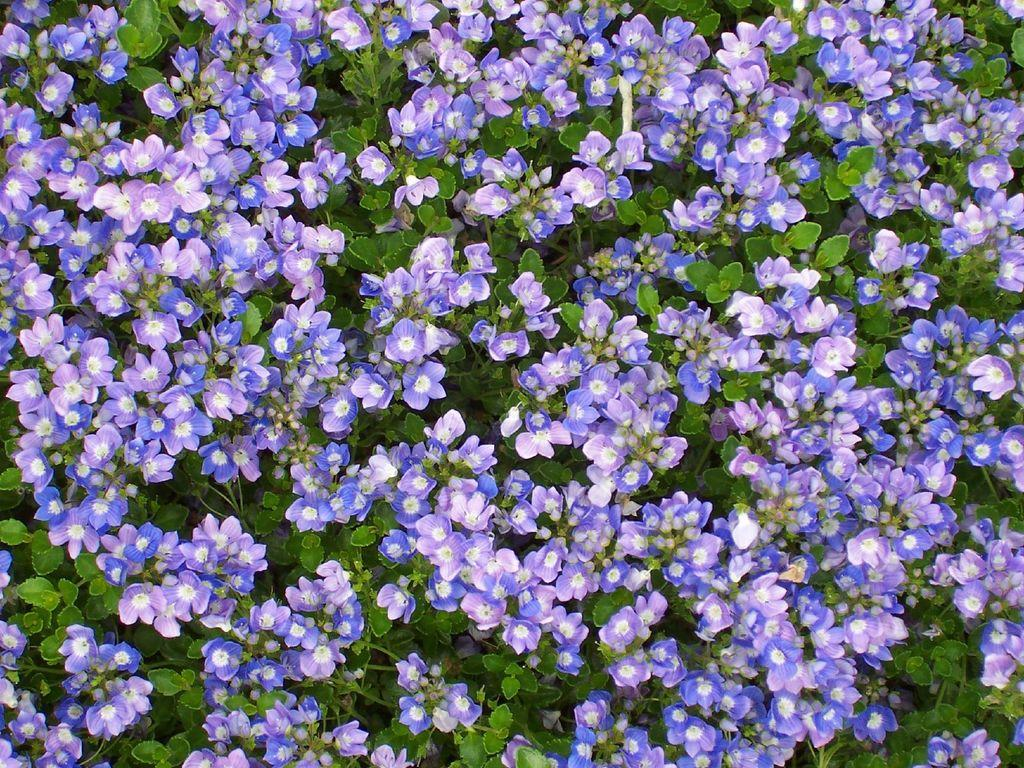What type of living organisms can be seen in the image? Flowers and plants can be seen in the image. Can you describe the specific types of plants or flowers visible in the image? Unfortunately, the provided facts do not specify the types of flowers or plants in the image. What type of calendar is displayed on the wall in the image? There is no mention of a calendar in the provided facts, so it cannot be determined if there is one present in the image. How does the toothpaste help the flowers in the image? There is no toothpaste present in the image, so it cannot be determined how it might help the flowers. 